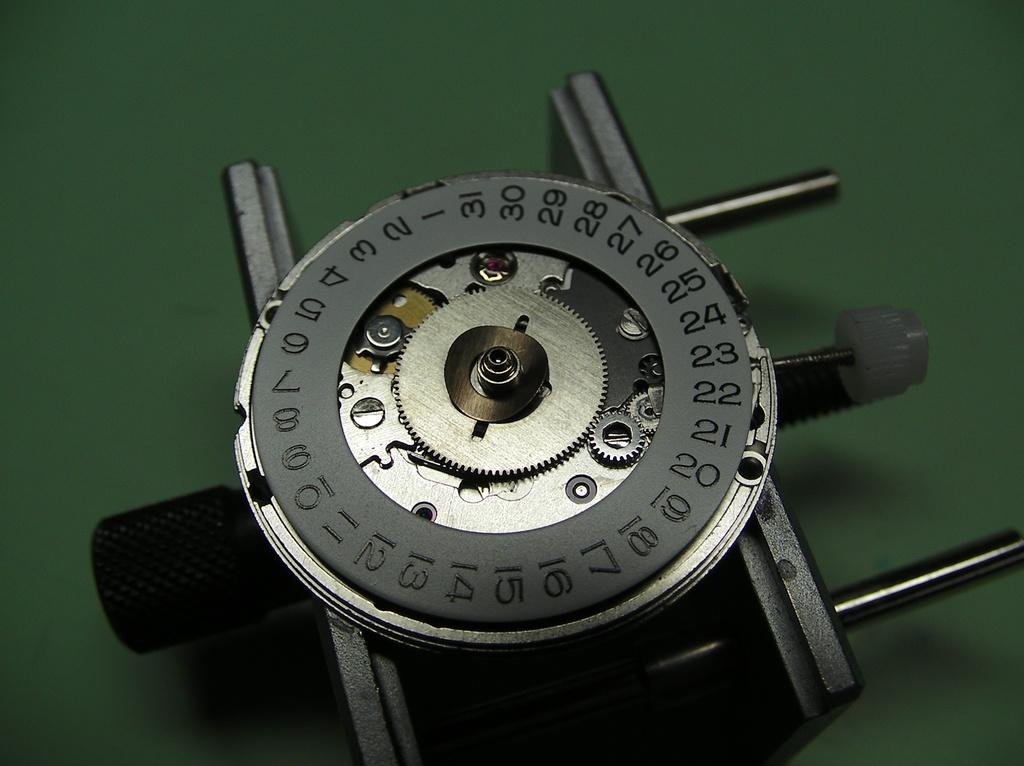<image>
Render a clear and concise summary of the photo. A disc has many numbers on it from "1" to "31". 